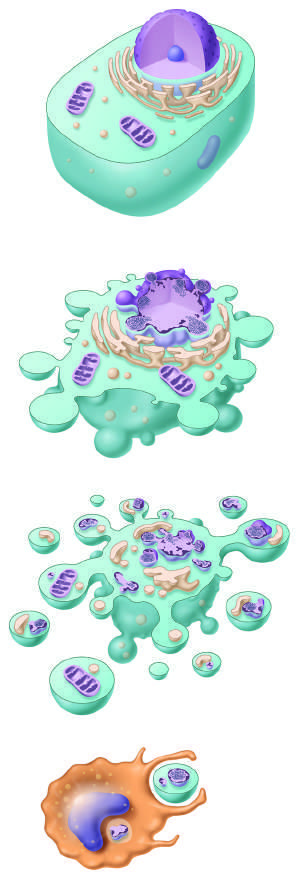re methylation of particular histone residues illustrated?
Answer the question using a single word or phrase. No 